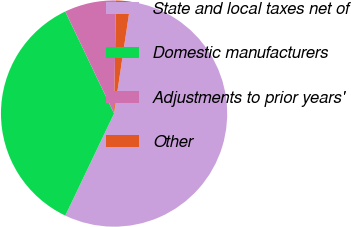<chart> <loc_0><loc_0><loc_500><loc_500><pie_chart><fcel>State and local taxes net of<fcel>Domestic manufacturers<fcel>Adjustments to prior years'<fcel>Other<nl><fcel>54.73%<fcel>35.81%<fcel>7.36%<fcel>2.1%<nl></chart> 